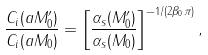Convert formula to latex. <formula><loc_0><loc_0><loc_500><loc_500>\frac { C _ { i } ( a M _ { 0 } ^ { \prime } ) } { C _ { i } ( a M _ { 0 } ) } = \left [ \frac { \alpha _ { s } ( M _ { 0 } ^ { \prime } ) } { \alpha _ { s } ( M _ { 0 } ) } \right ] ^ { - 1 / ( 2 \beta _ { 0 } \pi ) } ,</formula> 